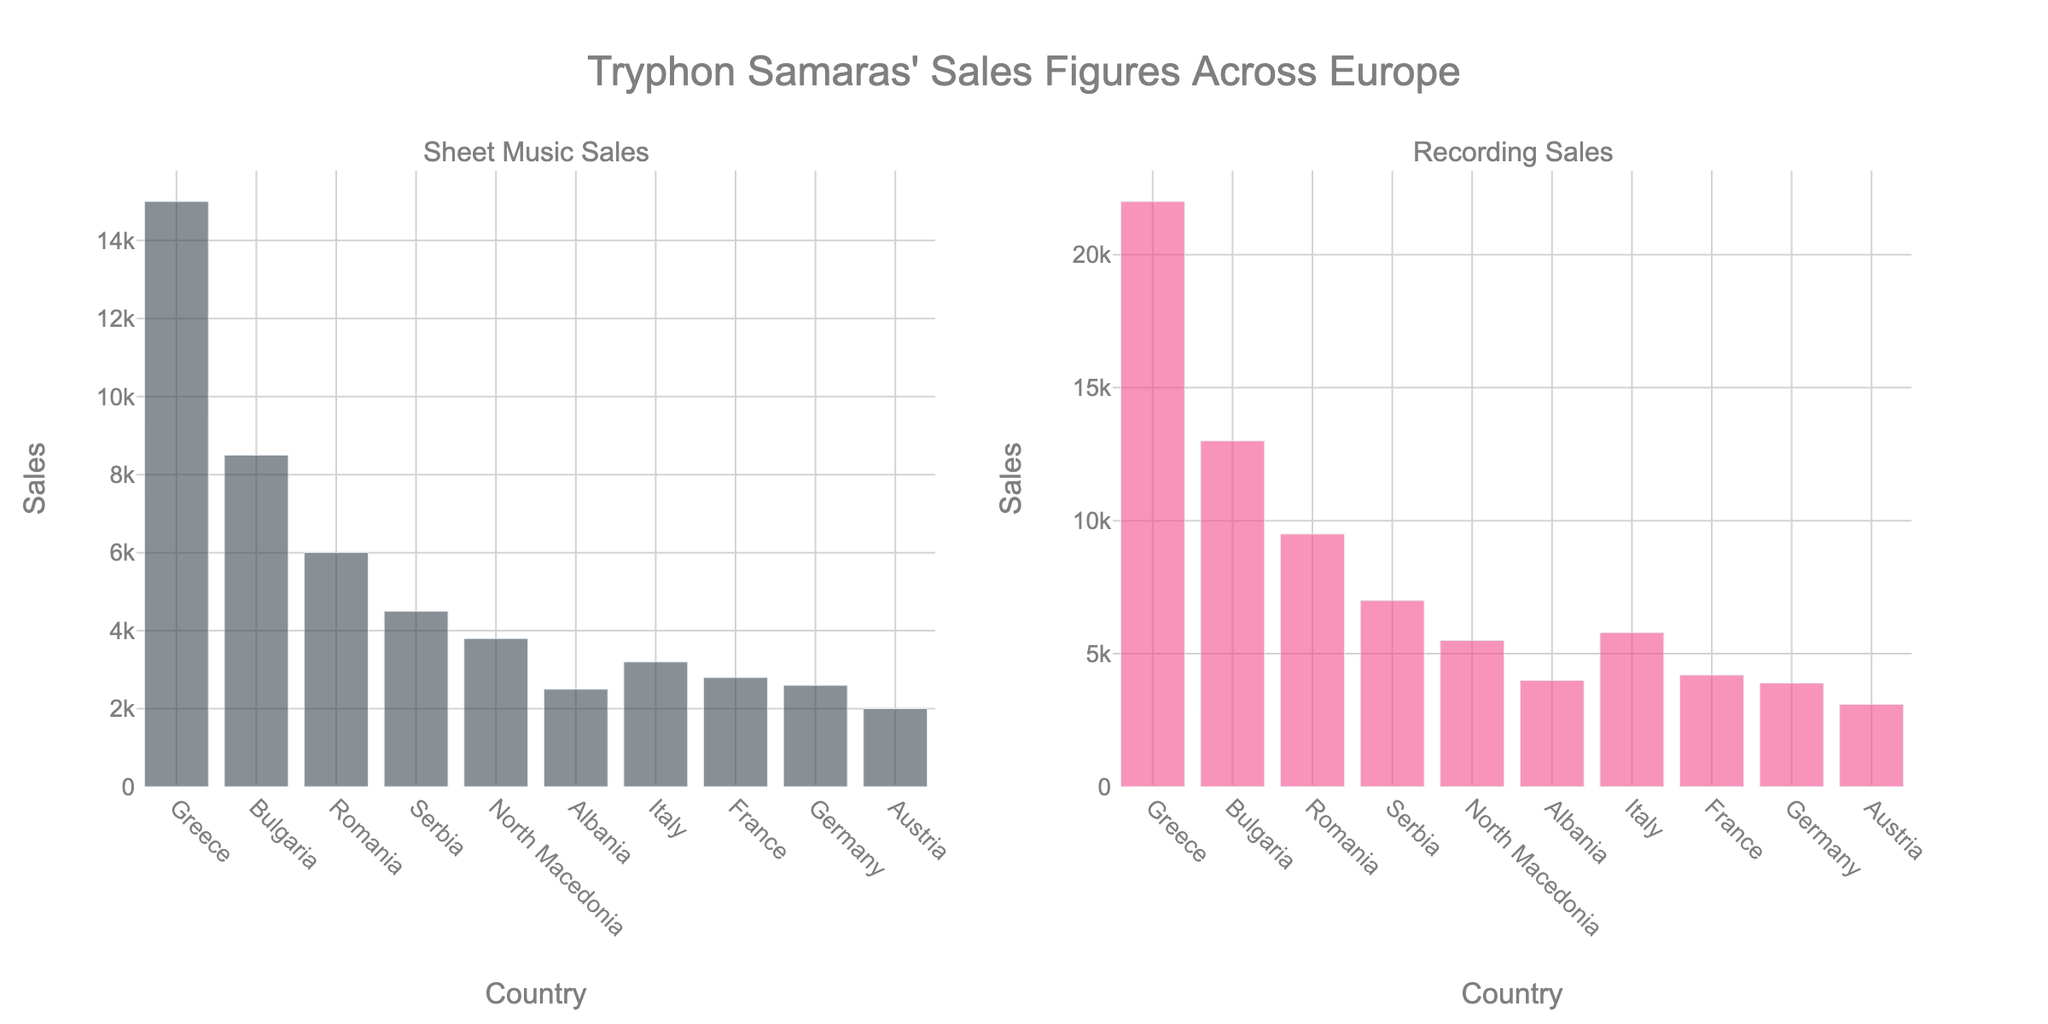What is the title of the figure? The title is displayed at the top of the figure. It is "Tryphon Samaras' Sales Figures Across Europe" in large font.
Answer: Tryphon Samaras' Sales Figures Across Europe Which country has the highest Sheet Music Sales? To determine which country has the highest Sheet Music Sales, look at the highest bar in the 'Sheet Music Sales' subplot. Greece has the highest bar.
Answer: Greece What is the difference in Recording Sales between Italy and Germany? Check the height of the bars for Italy and Germany in the 'Recording Sales' subplot. Italy has 5800 sales, and Germany has 3900. The difference is 5800 - 3900.
Answer: 1900 Compare the Sheet Music Sales and Recording Sales for Bulgaria. Are the Recording Sales higher or lower? For Bulgaria, refer to the bars in both subplots. In the 'Sheet Music Sales' subplot, the bar is 8500 and in the 'Recording Sales' subplot, the bar is 13000. Recording Sales are higher.
Answer: Higher What is the combined total of Sheet Music Sales and Recording Sales for Austria? Identify the bars in both subplots for Austria. The Sheet Music Sales are 2000, and the Recording Sales are 3100. Add them together (2000 + 3100).
Answer: 5100 How many countries have Sheet Music Sales greater than 5000? Examine the 'Sheet Music Sales' subplot and count the number of bars above the 5000 mark. The countries above this value are Greece, Bulgaria, and Romania.
Answer: 3 Which country has the smallest difference between Sheet Music Sales and Recording Sales? Check the absolute difference between the two sales figures for each country. Austria has Sheet Music Sales of 2000 and Recording Sales of 3100, giving a difference of 1100, which is the smallest among all countries.
Answer: Austria What is the average Recording Sales across all countries? Sum all the Recording Sales values (22000 + 13000 + 9500 + 7000 + 5500 + 4000 + 5800 + 4200 + 3900 + 3100 = 81800). Then divide by the number of countries (10).
Answer: 8180 